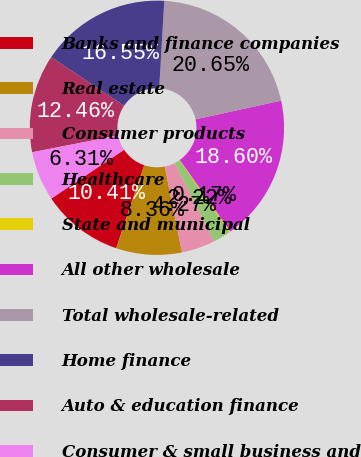Convert chart to OTSL. <chart><loc_0><loc_0><loc_500><loc_500><pie_chart><fcel>Banks and finance companies<fcel>Real estate<fcel>Consumer products<fcel>Healthcare<fcel>State and municipal<fcel>All other wholesale<fcel>Total wholesale-related<fcel>Home finance<fcel>Auto & education finance<fcel>Consumer & small business and<nl><fcel>10.41%<fcel>8.36%<fcel>4.27%<fcel>2.22%<fcel>0.17%<fcel>18.6%<fcel>20.65%<fcel>16.55%<fcel>12.46%<fcel>6.31%<nl></chart> 